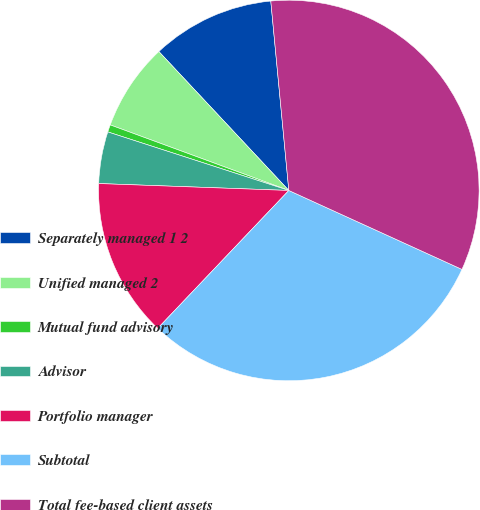<chart> <loc_0><loc_0><loc_500><loc_500><pie_chart><fcel>Separately managed 1 2<fcel>Unified managed 2<fcel>Mutual fund advisory<fcel>Advisor<fcel>Portfolio manager<fcel>Subtotal<fcel>Total fee-based client assets<nl><fcel>10.46%<fcel>7.43%<fcel>0.62%<fcel>4.4%<fcel>13.48%<fcel>30.29%<fcel>33.32%<nl></chart> 